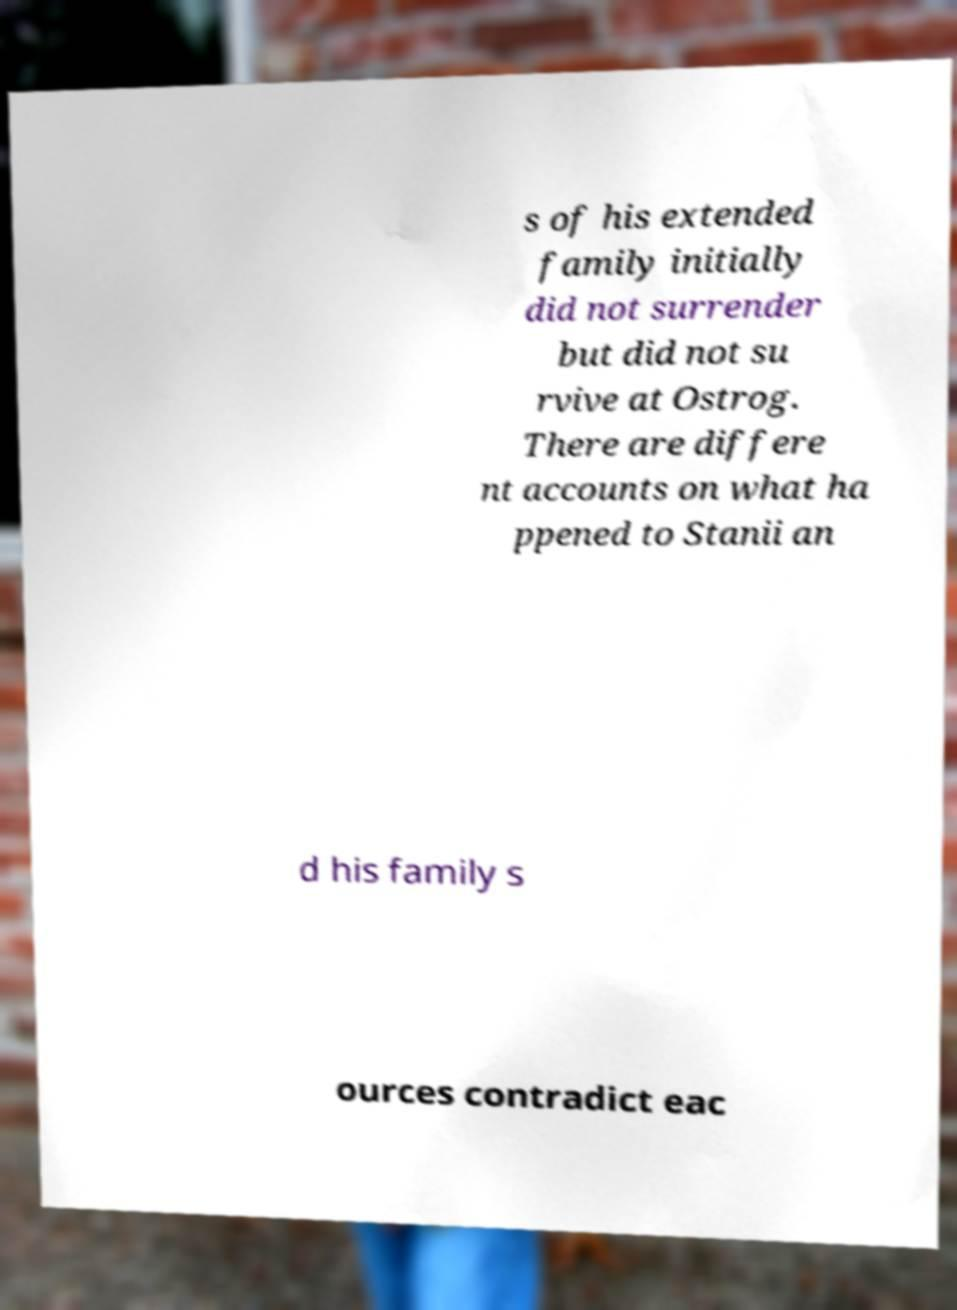Can you accurately transcribe the text from the provided image for me? s of his extended family initially did not surrender but did not su rvive at Ostrog. There are differe nt accounts on what ha ppened to Stanii an d his family s ources contradict eac 